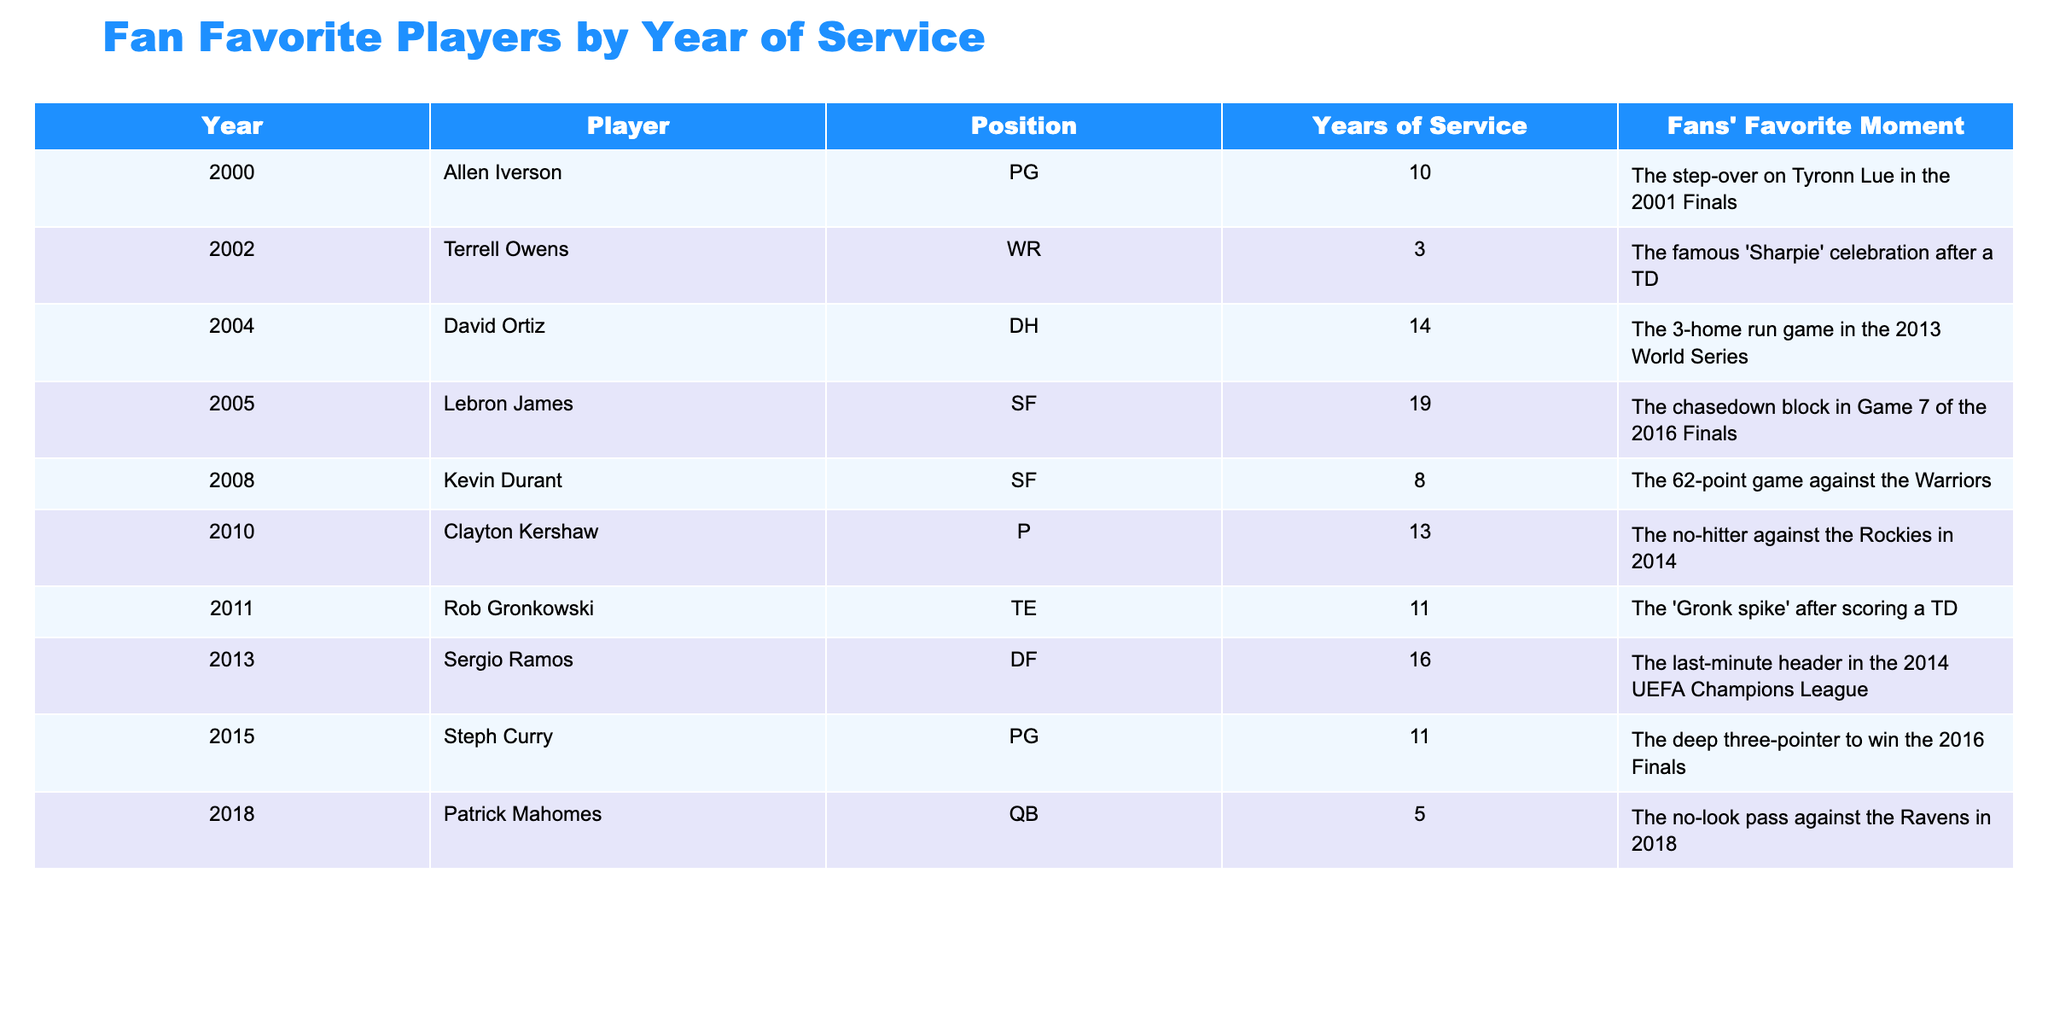What is the favorite moment of Allen Iverson? We can find Allen Iverson in the table under the year 2000, and his favorite moment is mentioned in the corresponding row. According to the table, it is "The step-over on Tyronn Lue in the 2001 Finals."
Answer: The step-over on Tyronn Lue in the 2001 Finals Who played the most years according to the table? The table lists players along with their years of service. By comparing the "Years of Service" column, David Ortiz has the highest value at 14 years.
Answer: David Ortiz Is there a player who served the same number of years as Steph Curry? Looking at the "Years of Service" column, Steph Curry served 11 years. We check the table to see if another player served this number of years. Both Rob Gronkowski and Steph Curry have 11 years of service.
Answer: Yes, Rob Gronkowski What is the sum of years of service for the players listed from 2000 to 2010? We gather the "Years of Service" for players from 2000 to 2010, which are 10 (Allen Iverson), 3 (Terrell Owens), 14 (David Ortiz), 19 (LeBron James), 8 (Kevin Durant), and 13 (Clayton Kershaw). Adding these together gives us 10 + 3 + 14 + 19 + 8 + 13 = 67.
Answer: 67 Which player had a moment related to a no-hitter? We look through the players' favorite moments to find specific mentions of a no-hitter. Clayton Kershaw’s moment states, "The no-hitter against the Rockies in 2014."
Answer: Clayton Kershaw What is the average years of service for the players listed? To find the average, we first sum the years of service for all players: 10 + 3 + 14 + 19 + 8 + 13 + 11 + 16 + 11 + 5 = 120. There are 10 players, so we divide by 10: 120 / 10 = 12.
Answer: 12 Which player had their favorite moment in 2018? We scan the table to find the player listed under the year 2018. That player is Patrick Mahomes, and his favorite moment is "The no-look pass against the Ravens in 2018."
Answer: Patrick Mahomes Was Steph Curry's favorite moment in the Finals? We check the row for Steph Curry's moment, which states, "The deep three-pointer to win the 2016 Finals." Since it mentions a specific Finals game, the answer is yes.
Answer: Yes Who had the least years of service and what was their favorite moment? Looking at the "Years of Service" column, we find Patrick Mahomes with 5 years, which is the least in the table. His favorite moment is "The no-look pass against the Ravens in 2018."
Answer: Patrick Mahomes; The no-look pass against the Ravens in 2018 What year did Terrell Owens become a fan favorite player? We find Terrell Owens listed in the table and see he was a fan favorite in 2002.
Answer: 2002 How many players have their favorite moment related to sports championships? We review the favorite moments: David Ortiz (World Series), LeBron James (NBA Finals), Steph Curry (NBA Finals), Sergio Ramos (Champions League). This gives us a total of 4 players.
Answer: 4 